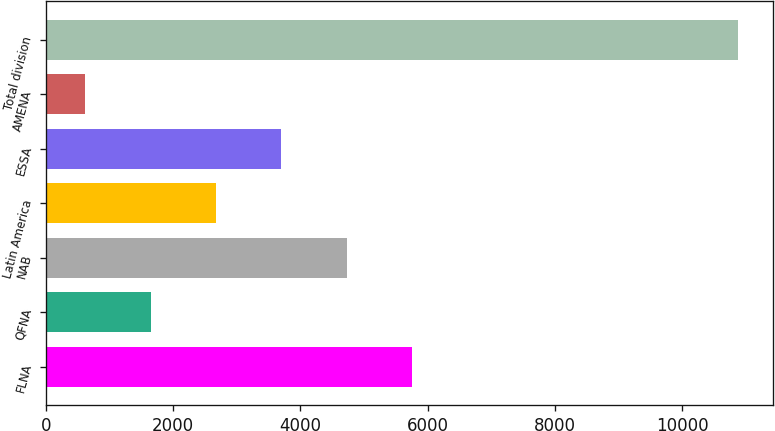<chart> <loc_0><loc_0><loc_500><loc_500><bar_chart><fcel>FLNA<fcel>QFNA<fcel>NAB<fcel>Latin America<fcel>ESSA<fcel>AMENA<fcel>Total division<nl><fcel>5752<fcel>1645.6<fcel>4725.4<fcel>2672.2<fcel>3698.8<fcel>619<fcel>10885<nl></chart> 